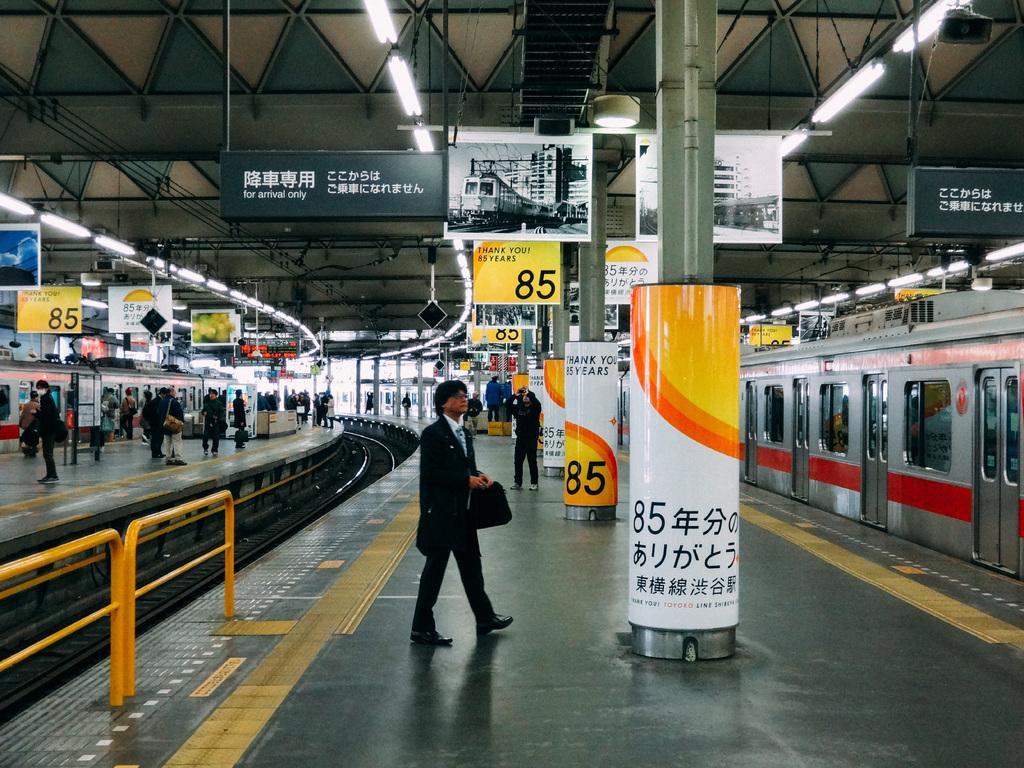In one or two sentences, can you explain what this image depicts? This image taken in a railway station, there is a train on the track, above the train there are a few boards with some text and images are hanging from the ceiling and there are lights, there are a few poles with some text on it. There are a few people standing and walking on the pavement with their luggage´s. On the left side of the image there is another track and there are some metal structures. 